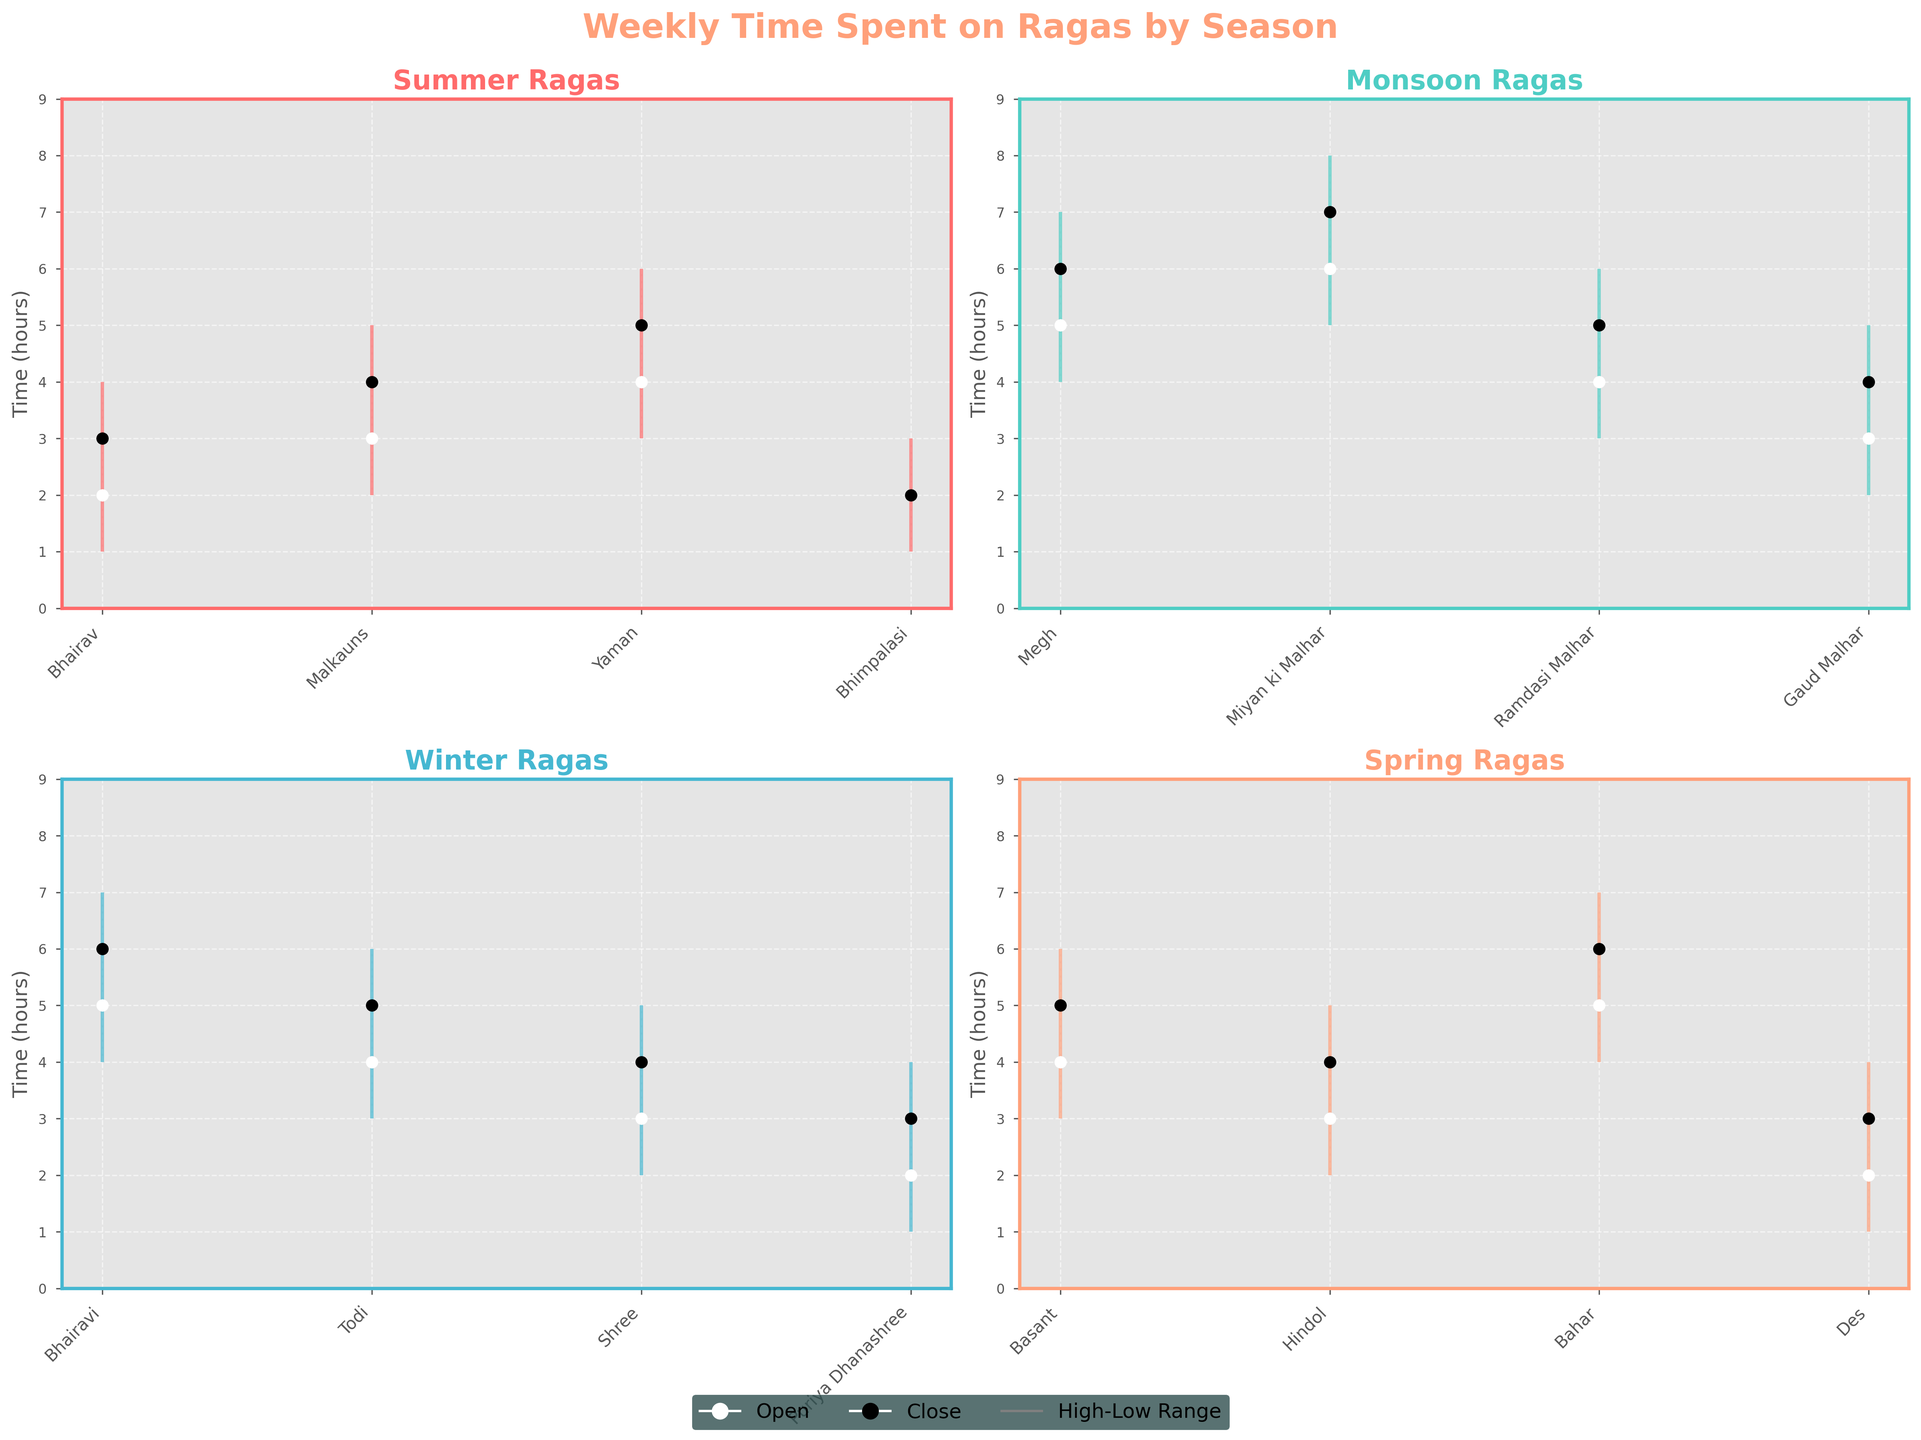Which season has the highest high value for time spent on a raga, and what is that value? Look at the maximum high values for each season and compare them. Monsoon has the highest high value of 8 hours.
Answer: Monsoon, 8 hours Which raga in Winter has the lowest open value? Observe the open values for each raga in Winter and identify the lowest. Puriya Dhanashree has the lowest open value of 2 hours.
Answer: Puriya Dhanashree What is the difference between the highest high value and the lowest low value in Summer? Find the highest high value (Yaman with 6 hours) and the lowest low value (Bhairav and Bhimpalasi with 1 hour) in Summer, and calculate the difference: 6 - 1 = 5 hours.
Answer: 5 hours How many ragas have been spent on in each season? Count the number of ragas listed for each season. Each has 4 ragas.
Answer: 4 Which raga in Monsoon has the highest close value? Check the close values for each raga in Monsoon and look for the highest one. Miyan ki Malhar has the highest close value of 7 hours.
Answer: Miyan ki Malhar Compare the range of time spent on Miyan ki Malhar and Bhimpalasi.Which has a bigger range? Calculate the range for both ragas. Miyan ki Malhar's range: 8 - 5 = 3, Bhimpalasi's range: 3 - 1 = 2. Miyan ki Malhar has a bigger range of 3 hours.
Answer: Miyan ki Malhar What is the average high value for ragas in Spring? Sum the high values for all Spring ragas (6+5+7+4 = 22) and divide by the number of ragas (4): 22 / 4 = 5.5 hours.
Answer: 5.5 hours Which season has the widest variability in time spent on ragas, and how can you tell? Compare the high-low ranges for each season's ragas and identify the season with the most variance. Monsoon has a variability range from 8 to 4 hours (4 hours), the widest among all seasons.
Answer: Monsoon, 4 hours Which raga in Summer has the lowest high value? Look at the high values for each raga in Summer and find the lowest. Bhimpalasi has the lowest high value of 3 hours.
Answer: Bhimpalasi 